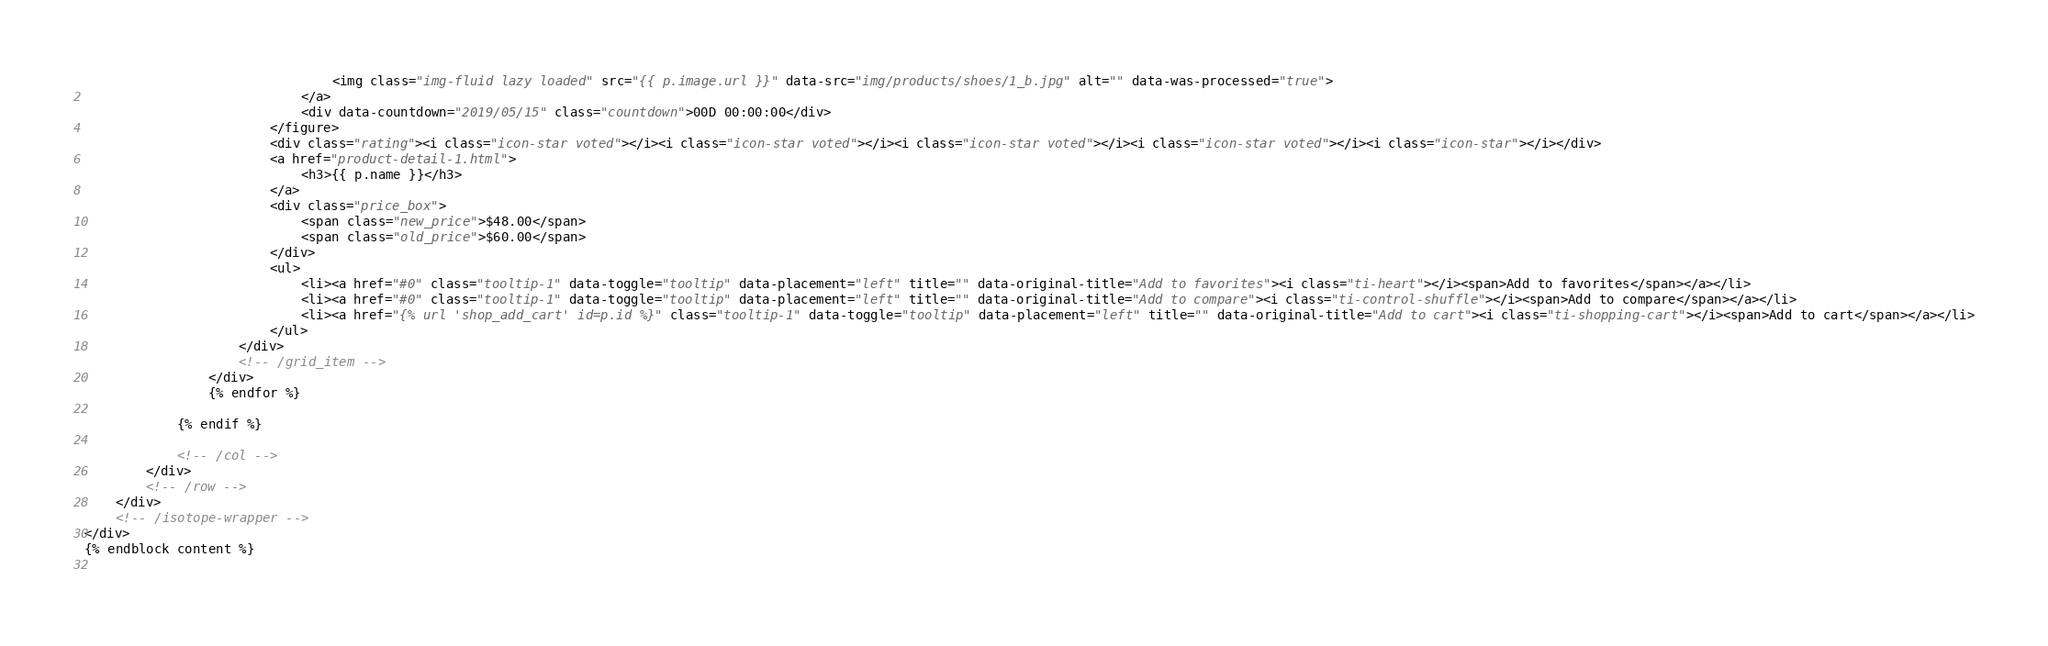<code> <loc_0><loc_0><loc_500><loc_500><_HTML_>                                <img class="img-fluid lazy loaded" src="{{ p.image.url }}" data-src="img/products/shoes/1_b.jpg" alt="" data-was-processed="true">
                            </a>
                            <div data-countdown="2019/05/15" class="countdown">00D 00:00:00</div>
                        </figure>
                        <div class="rating"><i class="icon-star voted"></i><i class="icon-star voted"></i><i class="icon-star voted"></i><i class="icon-star voted"></i><i class="icon-star"></i></div>
                        <a href="product-detail-1.html">
                            <h3>{{ p.name }}</h3>
                        </a>
                        <div class="price_box">
                            <span class="new_price">$48.00</span>
                            <span class="old_price">$60.00</span>
                        </div>
                        <ul>
                            <li><a href="#0" class="tooltip-1" data-toggle="tooltip" data-placement="left" title="" data-original-title="Add to favorites"><i class="ti-heart"></i><span>Add to favorites</span></a></li>
                            <li><a href="#0" class="tooltip-1" data-toggle="tooltip" data-placement="left" title="" data-original-title="Add to compare"><i class="ti-control-shuffle"></i><span>Add to compare</span></a></li>
                            <li><a href="{% url 'shop_add_cart' id=p.id %}" class="tooltip-1" data-toggle="tooltip" data-placement="left" title="" data-original-title="Add to cart"><i class="ti-shopping-cart"></i><span>Add to cart</span></a></li>
                        </ul>
                    </div>
                    <!-- /grid_item -->
                </div>
                {% endfor %}
                    
            {% endif %}
                
            <!-- /col -->
        </div>
        <!-- /row -->
    </div>
    <!-- /isotope-wrapper -->
</div>
{% endblock content %}
    </code> 